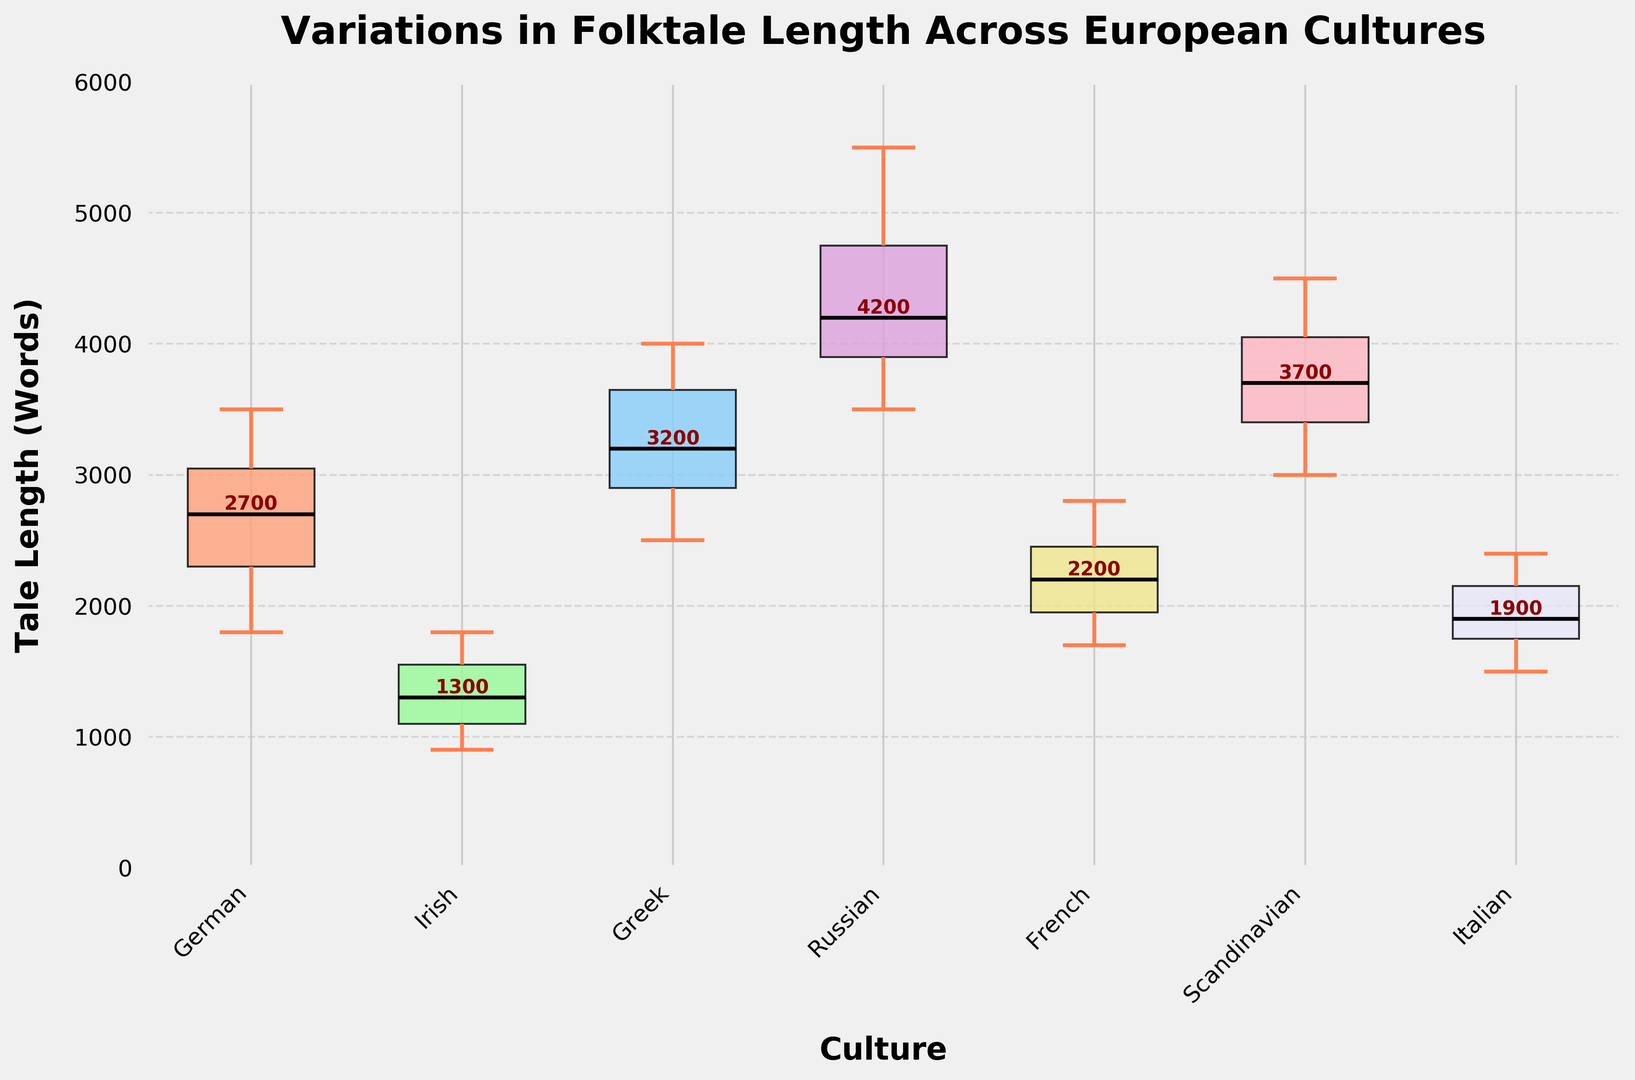Which culture has the highest median folktale length? The median line is the black line inside each box in the plot. By comparing these median lines, the Russian culture has the highest median folktale length.
Answer: Russian Which culture shows the smallest range in folktale lengths based on the interquartile range (IQR)? The IQR is the distance between the 25th and 75th percentiles, represented by the top and bottom edges of each box in the plot. Comparing these, the Irish culture shows the smallest range.
Answer: Irish What is the median folktale length for German culture? The median is the value indicated by the black line within the boxplot for German culture. According to the plot, the median for German culture is around 2700 words, as annotated in the plot.
Answer: 2700 Which culture has the widest range of folktale lengths, considering the whisker lengths? The whiskers extend to the minimum and maximum values within 1.5 times the IQR from the quartiles. The Russian culture shows the widest range, extending from 3500 to 5500 words.
Answer: Russian How do the median folktale lengths of Greek and French cultures compare? The median is indicated by the black line within each boxplot. The Greek culture has a median value higher than the French culture. Specifically, the Greek median is about 3200 words, whereas the French median is around 2200 words.
Answer: Greek is higher What is the interquartile range (IQR) for the Italian culture? The IQR is calculated by subtracting the value at the 25th percentile from the value at the 75th percentile, represented by the top and bottom edges of the boxplot. For Italian culture, the IQR is from about 1700 to 2200 words, so the range is 2200 - 1700 = 500.
Answer: 500 Which cultures have similar median folktale lengths? By comparing the median lines across cultures, the German and Greek cultures have similar median folktale lengths, around 2700 and 3200 respectively. These median lines are closer in value when compared to the others.
Answer: German and Greek What is the maximum folktale length recorded in the Scandinavian culture according to the plot? The maximum value is indicated by the tip of the upper whisker. For the Scandinavian culture, the maximum value extends to about 4500 words.
Answer: 4500 How does the variation in folktale length in Irish culture compare to the rest? The Irish culture shows a much smaller variation in folktale length compared to others, as indicated by the shorter length of the whiskers and the smaller interquartile range.
Answer: Smaller variation Which culture has the lowest median folktale length? The median is indicated by the black line within the boxplot. Among the cultures, the Irish culture has the lowest median folktale length, around 1300 words.
Answer: Irish 